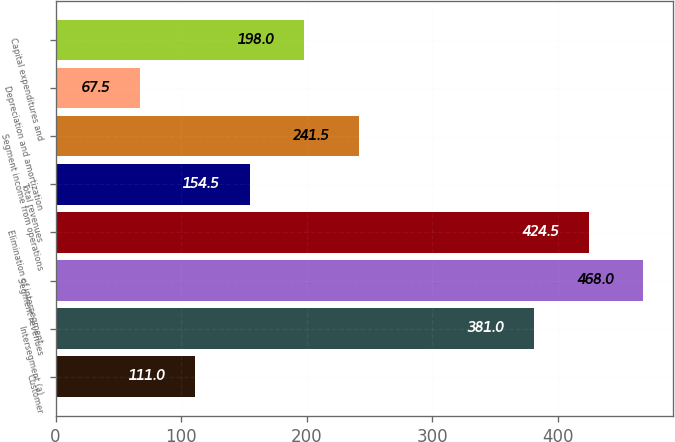Convert chart to OTSL. <chart><loc_0><loc_0><loc_500><loc_500><bar_chart><fcel>Customer<fcel>Intersegment (a)<fcel>Segment revenues<fcel>Elimination of intersegment<fcel>Total revenues<fcel>Segment income from operations<fcel>Depreciation and amortization<fcel>Capital expenditures and<nl><fcel>111<fcel>381<fcel>468<fcel>424.5<fcel>154.5<fcel>241.5<fcel>67.5<fcel>198<nl></chart> 